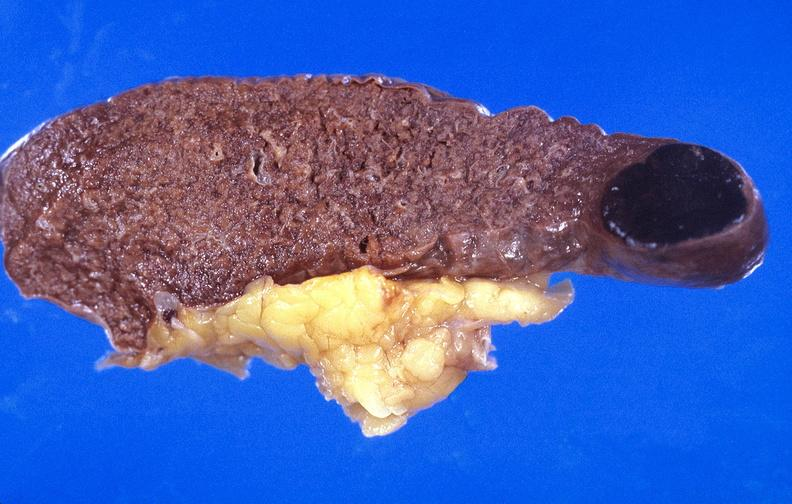s hematologic present?
Answer the question using a single word or phrase. Yes 